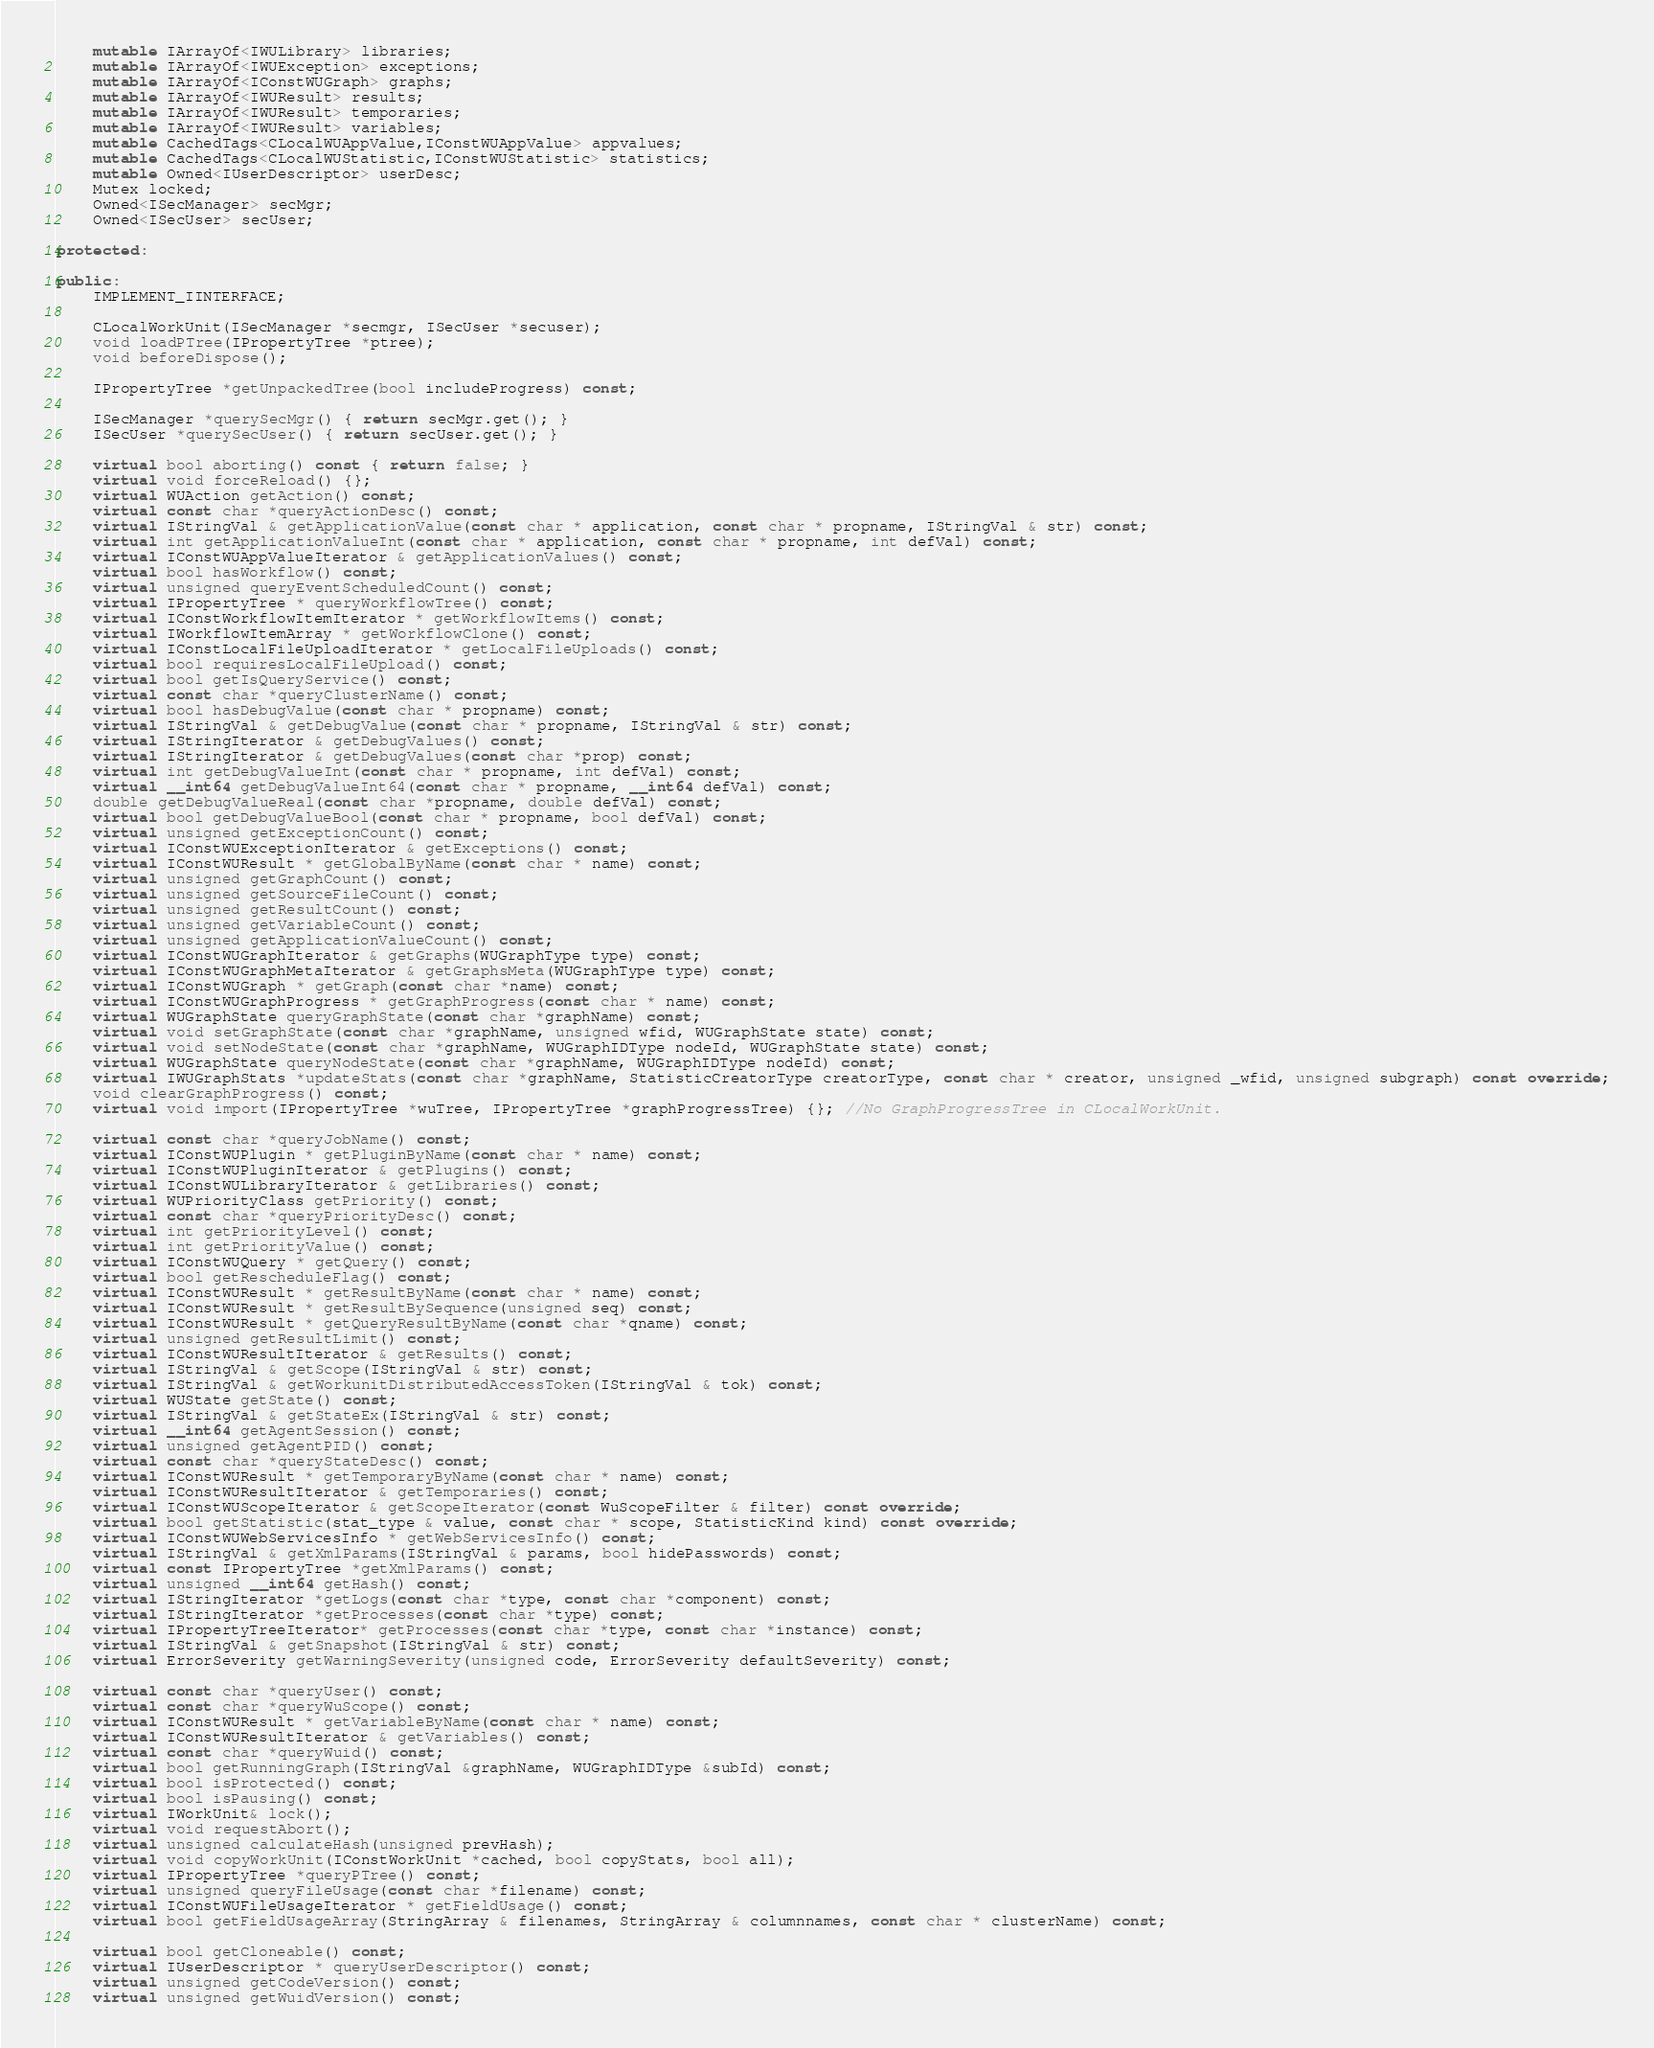<code> <loc_0><loc_0><loc_500><loc_500><_C++_>    mutable IArrayOf<IWULibrary> libraries;
    mutable IArrayOf<IWUException> exceptions;
    mutable IArrayOf<IConstWUGraph> graphs;
    mutable IArrayOf<IWUResult> results;
    mutable IArrayOf<IWUResult> temporaries;
    mutable IArrayOf<IWUResult> variables;
    mutable CachedTags<CLocalWUAppValue,IConstWUAppValue> appvalues;
    mutable CachedTags<CLocalWUStatistic,IConstWUStatistic> statistics;
    mutable Owned<IUserDescriptor> userDesc;
    Mutex locked;
    Owned<ISecManager> secMgr;
    Owned<ISecUser> secUser;

protected:
    
public:
    IMPLEMENT_IINTERFACE;

    CLocalWorkUnit(ISecManager *secmgr, ISecUser *secuser);
    void loadPTree(IPropertyTree *ptree);
    void beforeDispose();
    
    IPropertyTree *getUnpackedTree(bool includeProgress) const;

    ISecManager *querySecMgr() { return secMgr.get(); }
    ISecUser *querySecUser() { return secUser.get(); }

    virtual bool aborting() const { return false; }
    virtual void forceReload() {};
    virtual WUAction getAction() const;
    virtual const char *queryActionDesc() const;
    virtual IStringVal & getApplicationValue(const char * application, const char * propname, IStringVal & str) const;
    virtual int getApplicationValueInt(const char * application, const char * propname, int defVal) const;
    virtual IConstWUAppValueIterator & getApplicationValues() const;
    virtual bool hasWorkflow() const;
    virtual unsigned queryEventScheduledCount() const;
    virtual IPropertyTree * queryWorkflowTree() const;
    virtual IConstWorkflowItemIterator * getWorkflowItems() const;
    virtual IWorkflowItemArray * getWorkflowClone() const;
    virtual IConstLocalFileUploadIterator * getLocalFileUploads() const;
    virtual bool requiresLocalFileUpload() const;
    virtual bool getIsQueryService() const;
    virtual const char *queryClusterName() const;
    virtual bool hasDebugValue(const char * propname) const;
    virtual IStringVal & getDebugValue(const char * propname, IStringVal & str) const;
    virtual IStringIterator & getDebugValues() const;
    virtual IStringIterator & getDebugValues(const char *prop) const;
    virtual int getDebugValueInt(const char * propname, int defVal) const;
    virtual __int64 getDebugValueInt64(const char * propname, __int64 defVal) const;
    double getDebugValueReal(const char *propname, double defVal) const;
    virtual bool getDebugValueBool(const char * propname, bool defVal) const;
    virtual unsigned getExceptionCount() const;
    virtual IConstWUExceptionIterator & getExceptions() const;
    virtual IConstWUResult * getGlobalByName(const char * name) const;
    virtual unsigned getGraphCount() const;
    virtual unsigned getSourceFileCount() const;
    virtual unsigned getResultCount() const;
    virtual unsigned getVariableCount() const;
    virtual unsigned getApplicationValueCount() const;
    virtual IConstWUGraphIterator & getGraphs(WUGraphType type) const;
    virtual IConstWUGraphMetaIterator & getGraphsMeta(WUGraphType type) const;
    virtual IConstWUGraph * getGraph(const char *name) const;
    virtual IConstWUGraphProgress * getGraphProgress(const char * name) const;
    virtual WUGraphState queryGraphState(const char *graphName) const;
    virtual void setGraphState(const char *graphName, unsigned wfid, WUGraphState state) const;
    virtual void setNodeState(const char *graphName, WUGraphIDType nodeId, WUGraphState state) const;
    virtual WUGraphState queryNodeState(const char *graphName, WUGraphIDType nodeId) const;
    virtual IWUGraphStats *updateStats(const char *graphName, StatisticCreatorType creatorType, const char * creator, unsigned _wfid, unsigned subgraph) const override;
    void clearGraphProgress() const;
    virtual void import(IPropertyTree *wuTree, IPropertyTree *graphProgressTree) {}; //No GraphProgressTree in CLocalWorkUnit.

    virtual const char *queryJobName() const;
    virtual IConstWUPlugin * getPluginByName(const char * name) const;
    virtual IConstWUPluginIterator & getPlugins() const;
    virtual IConstWULibraryIterator & getLibraries() const;
    virtual WUPriorityClass getPriority() const;
    virtual const char *queryPriorityDesc() const;
    virtual int getPriorityLevel() const;
    virtual int getPriorityValue() const;
    virtual IConstWUQuery * getQuery() const;
    virtual bool getRescheduleFlag() const;
    virtual IConstWUResult * getResultByName(const char * name) const;
    virtual IConstWUResult * getResultBySequence(unsigned seq) const;
    virtual IConstWUResult * getQueryResultByName(const char *qname) const;
    virtual unsigned getResultLimit() const;
    virtual IConstWUResultIterator & getResults() const;
    virtual IStringVal & getScope(IStringVal & str) const;
    virtual IStringVal & getWorkunitDistributedAccessToken(IStringVal & tok) const;
    virtual WUState getState() const;
    virtual IStringVal & getStateEx(IStringVal & str) const;
    virtual __int64 getAgentSession() const;
    virtual unsigned getAgentPID() const;
    virtual const char *queryStateDesc() const;
    virtual IConstWUResult * getTemporaryByName(const char * name) const;
    virtual IConstWUResultIterator & getTemporaries() const;
    virtual IConstWUScopeIterator & getScopeIterator(const WuScopeFilter & filter) const override;
    virtual bool getStatistic(stat_type & value, const char * scope, StatisticKind kind) const override;
    virtual IConstWUWebServicesInfo * getWebServicesInfo() const;
    virtual IStringVal & getXmlParams(IStringVal & params, bool hidePasswords) const;
    virtual const IPropertyTree *getXmlParams() const;
    virtual unsigned __int64 getHash() const;
    virtual IStringIterator *getLogs(const char *type, const char *component) const;
    virtual IStringIterator *getProcesses(const char *type) const;
    virtual IPropertyTreeIterator* getProcesses(const char *type, const char *instance) const;
    virtual IStringVal & getSnapshot(IStringVal & str) const;
    virtual ErrorSeverity getWarningSeverity(unsigned code, ErrorSeverity defaultSeverity) const;

    virtual const char *queryUser() const;
    virtual const char *queryWuScope() const;
    virtual IConstWUResult * getVariableByName(const char * name) const;
    virtual IConstWUResultIterator & getVariables() const;
    virtual const char *queryWuid() const;
    virtual bool getRunningGraph(IStringVal &graphName, WUGraphIDType &subId) const;
    virtual bool isProtected() const;
    virtual bool isPausing() const;
    virtual IWorkUnit& lock();
    virtual void requestAbort();
    virtual unsigned calculateHash(unsigned prevHash);
    virtual void copyWorkUnit(IConstWorkUnit *cached, bool copyStats, bool all);
    virtual IPropertyTree *queryPTree() const;
    virtual unsigned queryFileUsage(const char *filename) const;
    virtual IConstWUFileUsageIterator * getFieldUsage() const;
    virtual bool getFieldUsageArray(StringArray & filenames, StringArray & columnnames, const char * clusterName) const;

    virtual bool getCloneable() const;
    virtual IUserDescriptor * queryUserDescriptor() const;
    virtual unsigned getCodeVersion() const;
    virtual unsigned getWuidVersion() const;</code> 